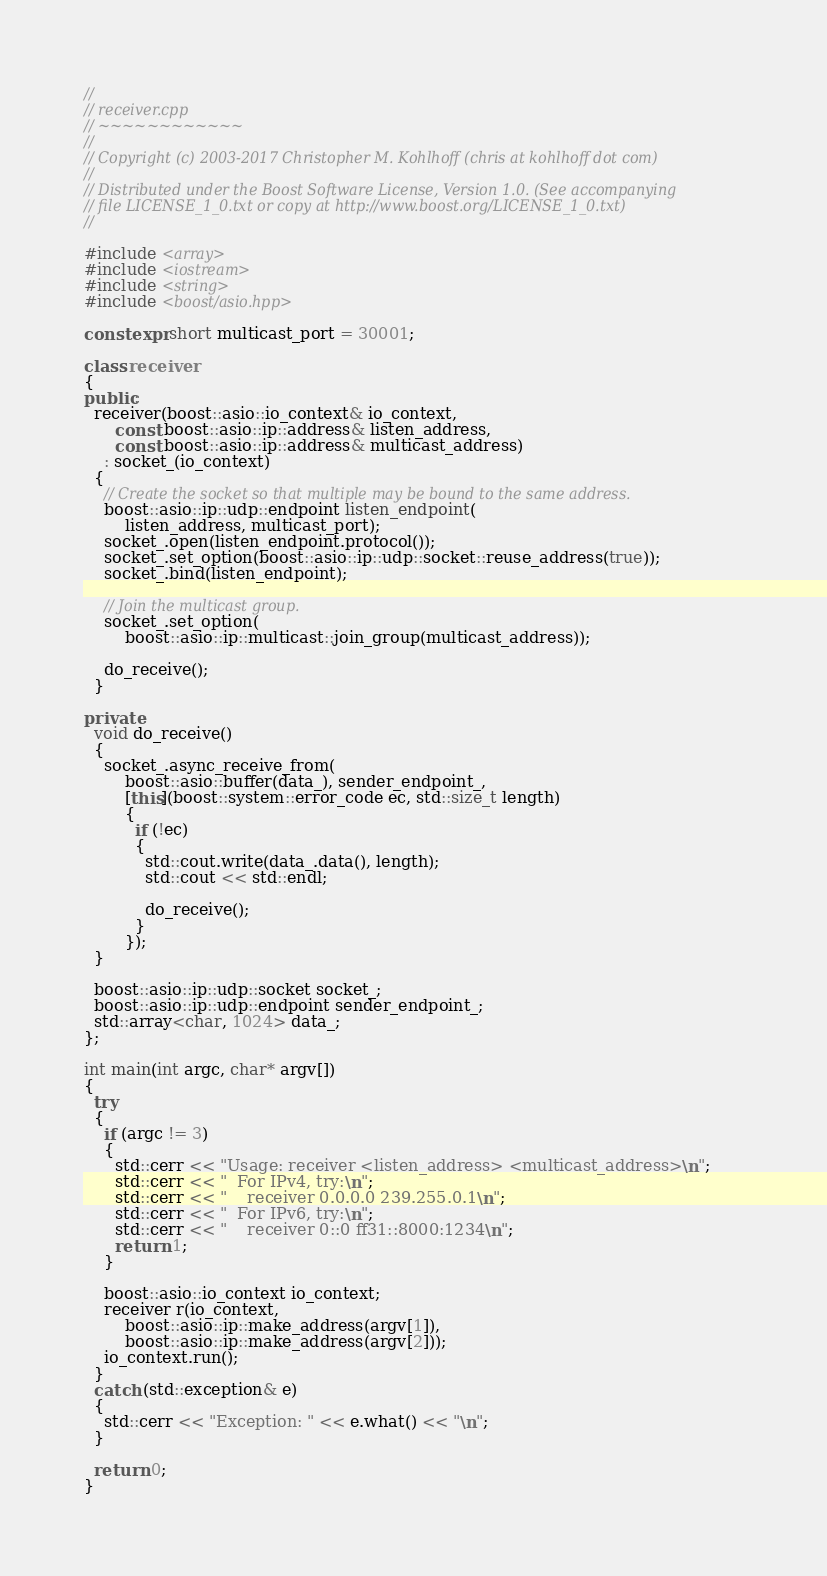Convert code to text. <code><loc_0><loc_0><loc_500><loc_500><_C++_>//
// receiver.cpp
// ~~~~~~~~~~~~
//
// Copyright (c) 2003-2017 Christopher M. Kohlhoff (chris at kohlhoff dot com)
//
// Distributed under the Boost Software License, Version 1.0. (See accompanying
// file LICENSE_1_0.txt or copy at http://www.boost.org/LICENSE_1_0.txt)
//

#include <array>
#include <iostream>
#include <string>
#include <boost/asio.hpp>

constexpr short multicast_port = 30001;

class receiver
{
public:
  receiver(boost::asio::io_context& io_context,
      const boost::asio::ip::address& listen_address,
      const boost::asio::ip::address& multicast_address)
    : socket_(io_context)
  {
    // Create the socket so that multiple may be bound to the same address.
    boost::asio::ip::udp::endpoint listen_endpoint(
        listen_address, multicast_port);
    socket_.open(listen_endpoint.protocol());
    socket_.set_option(boost::asio::ip::udp::socket::reuse_address(true));
    socket_.bind(listen_endpoint);

    // Join the multicast group.
    socket_.set_option(
        boost::asio::ip::multicast::join_group(multicast_address));

    do_receive();
  }

private:
  void do_receive()
  {
    socket_.async_receive_from(
        boost::asio::buffer(data_), sender_endpoint_,
        [this](boost::system::error_code ec, std::size_t length)
        {
          if (!ec)
          {
            std::cout.write(data_.data(), length);
            std::cout << std::endl;

            do_receive();
          }
        });
  }

  boost::asio::ip::udp::socket socket_;
  boost::asio::ip::udp::endpoint sender_endpoint_;
  std::array<char, 1024> data_;
};

int main(int argc, char* argv[])
{
  try
  {
    if (argc != 3)
    {
      std::cerr << "Usage: receiver <listen_address> <multicast_address>\n";
      std::cerr << "  For IPv4, try:\n";
      std::cerr << "    receiver 0.0.0.0 239.255.0.1\n";
      std::cerr << "  For IPv6, try:\n";
      std::cerr << "    receiver 0::0 ff31::8000:1234\n";
      return 1;
    }

    boost::asio::io_context io_context;
    receiver r(io_context,
        boost::asio::ip::make_address(argv[1]),
        boost::asio::ip::make_address(argv[2]));
    io_context.run();
  }
  catch (std::exception& e)
  {
    std::cerr << "Exception: " << e.what() << "\n";
  }

  return 0;
}
</code> 